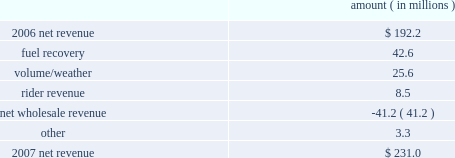Entergy new orleans , inc .
Management's financial discussion and analysis 2007 compared to 2006 net revenue consists of operating revenues net of : 1 ) fuel , fuel-related expenses , and gas purchased for resale , 2 ) purchased power expenses , and 3 ) other regulatory charges .
Following is an analysis of the change in net revenue comparing 2007 to 2006 .
Amount ( in millions ) .
The fuel recovery variance is due to the inclusion of grand gulf costs in fuel recoveries effective july 1 , 2006 .
In june 2006 , the city council approved the recovery of grand gulf costs through the fuel adjustment clause , without a corresponding change in base rates ( a significant portion of grand gulf costs was previously recovered through base rates ) .
The volume/weather variance is due to an increase in electricity usage in the service territory in 2007 compared to the same period in 2006 .
The first quarter 2006 was affected by customer losses following hurricane katrina .
Entergy new orleans estimates that approximately 132000 electric customers and 86000 gas customers have returned and are taking service as of december 31 , 2007 , compared to approximately 95000 electric customers and 65000 gas customers as of december 31 , 2006 .
Billed retail electricity usage increased a total of 540 gwh compared to the same period in 2006 , an increase of 14% ( 14 % ) .
The rider revenue variance is due primarily to a storm reserve rider effective march 2007 as a result of the city council's approval of a settlement agreement in october 2006 .
The approved storm reserve has been set to collect $ 75 million over a ten-year period through the rider and the funds will be held in a restricted escrow account .
The settlement agreement is discussed in note 2 to the financial statements .
The net wholesale revenue variance is due to more energy available for resale in 2006 due to the decrease in retail usage caused by customer losses following hurricane katrina .
In addition , 2006 revenue includes the sales into the wholesale market of entergy new orleans' share of the output of grand gulf , pursuant to city council approval of measures proposed by entergy new orleans to address the reduction in entergy new orleans' retail customer usage caused by hurricane katrina and to provide revenue support for the costs of entergy new orleans' share of grand other income statement variances 2008 compared to 2007 other operation and maintenance expenses decreased primarily due to : a provision for storm-related bad debts of $ 11 million recorded in 2007 ; a decrease of $ 6.2 million in legal and professional fees ; a decrease of $ 3.4 million in employee benefit expenses ; and a decrease of $ 1.9 million in gas operations spending due to higher labor and material costs for reliability work in 2007. .
What is the growth rate in net revenue in 2007 compare to 2006 for entergy new orleans , inc.? 
Computations: ((231.0 - 192.2) / 192.2)
Answer: 0.20187. 